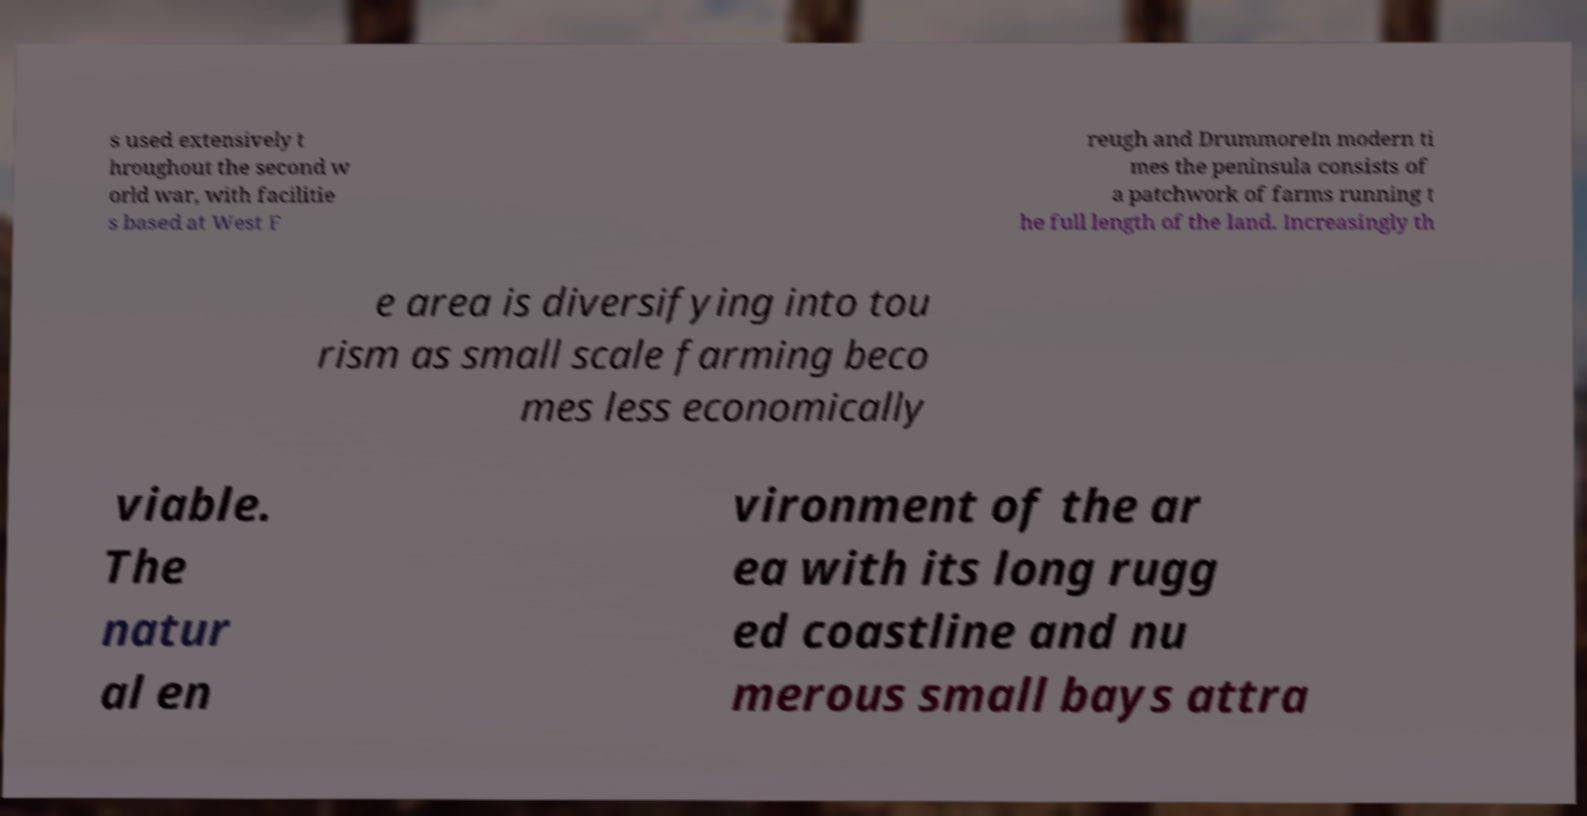Can you accurately transcribe the text from the provided image for me? s used extensively t hroughout the second w orld war, with facilitie s based at West F reugh and DrummoreIn modern ti mes the peninsula consists of a patchwork of farms running t he full length of the land. Increasingly th e area is diversifying into tou rism as small scale farming beco mes less economically viable. The natur al en vironment of the ar ea with its long rugg ed coastline and nu merous small bays attra 